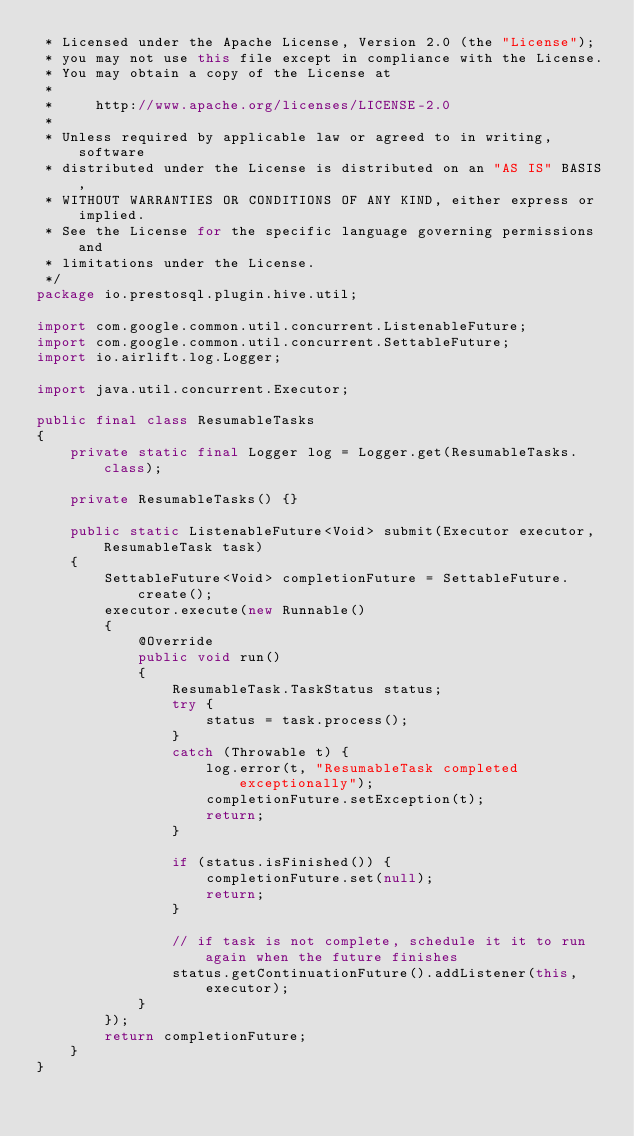Convert code to text. <code><loc_0><loc_0><loc_500><loc_500><_Java_> * Licensed under the Apache License, Version 2.0 (the "License");
 * you may not use this file except in compliance with the License.
 * You may obtain a copy of the License at
 *
 *     http://www.apache.org/licenses/LICENSE-2.0
 *
 * Unless required by applicable law or agreed to in writing, software
 * distributed under the License is distributed on an "AS IS" BASIS,
 * WITHOUT WARRANTIES OR CONDITIONS OF ANY KIND, either express or implied.
 * See the License for the specific language governing permissions and
 * limitations under the License.
 */
package io.prestosql.plugin.hive.util;

import com.google.common.util.concurrent.ListenableFuture;
import com.google.common.util.concurrent.SettableFuture;
import io.airlift.log.Logger;

import java.util.concurrent.Executor;

public final class ResumableTasks
{
    private static final Logger log = Logger.get(ResumableTasks.class);

    private ResumableTasks() {}

    public static ListenableFuture<Void> submit(Executor executor, ResumableTask task)
    {
        SettableFuture<Void> completionFuture = SettableFuture.create();
        executor.execute(new Runnable()
        {
            @Override
            public void run()
            {
                ResumableTask.TaskStatus status;
                try {
                    status = task.process();
                }
                catch (Throwable t) {
                    log.error(t, "ResumableTask completed exceptionally");
                    completionFuture.setException(t);
                    return;
                }

                if (status.isFinished()) {
                    completionFuture.set(null);
                    return;
                }

                // if task is not complete, schedule it it to run again when the future finishes
                status.getContinuationFuture().addListener(this, executor);
            }
        });
        return completionFuture;
    }
}
</code> 